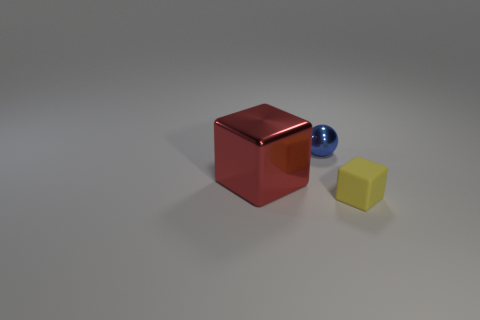Add 1 tiny brown matte blocks. How many objects exist? 4 Subtract all blocks. How many objects are left? 1 Subtract all big brown cubes. Subtract all blue things. How many objects are left? 2 Add 2 red objects. How many red objects are left? 3 Add 3 blue metal spheres. How many blue metal spheres exist? 4 Subtract 0 yellow cylinders. How many objects are left? 3 Subtract all yellow cubes. Subtract all green balls. How many cubes are left? 1 